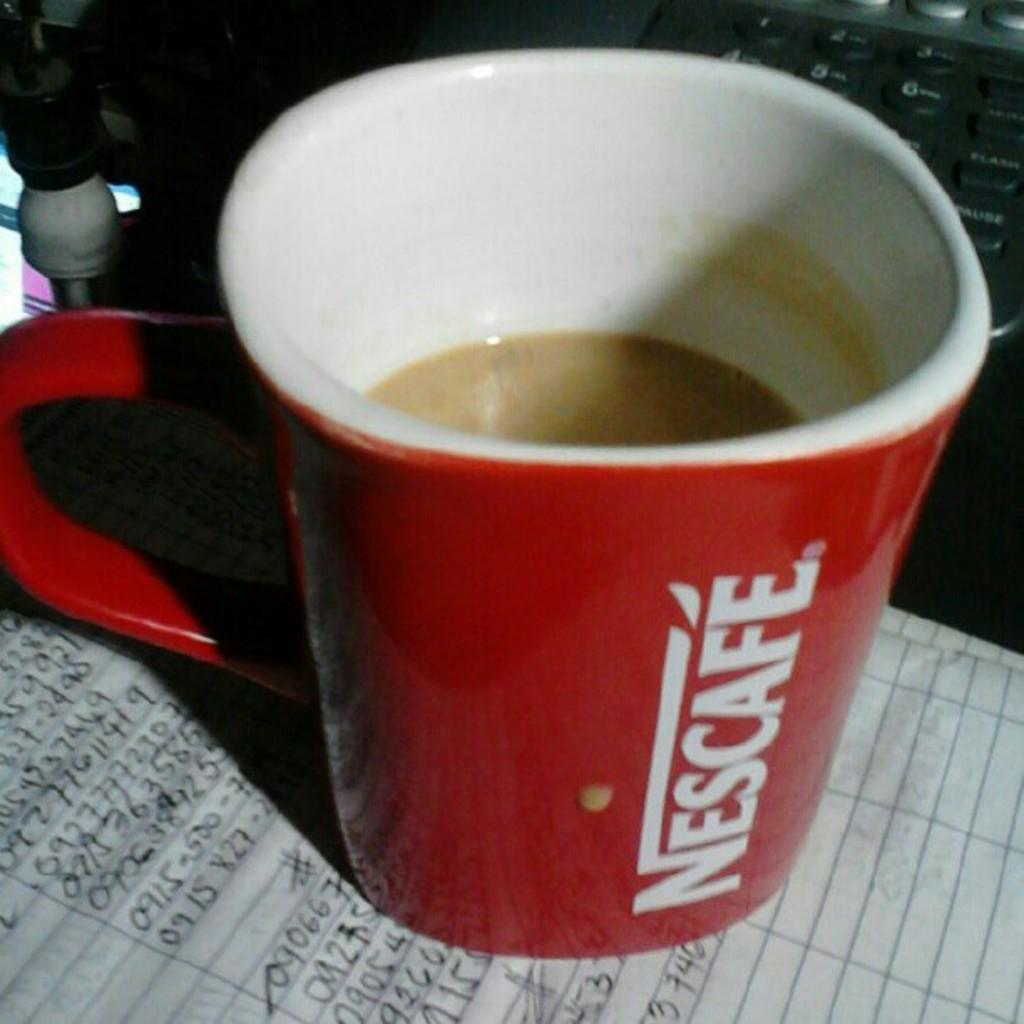<image>
Relay a brief, clear account of the picture shown. A cup of Nescafe sits on a paper with lines of handwritten numbers. 